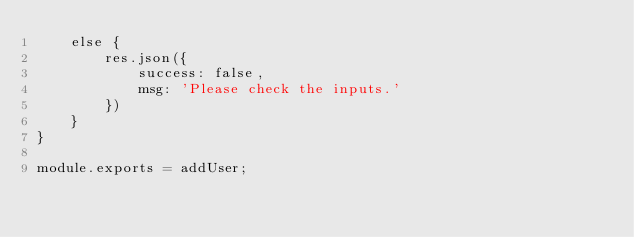<code> <loc_0><loc_0><loc_500><loc_500><_JavaScript_>    else {
        res.json({
            success: false,
            msg: 'Please check the inputs.'
        })
    }
}

module.exports = addUser;</code> 